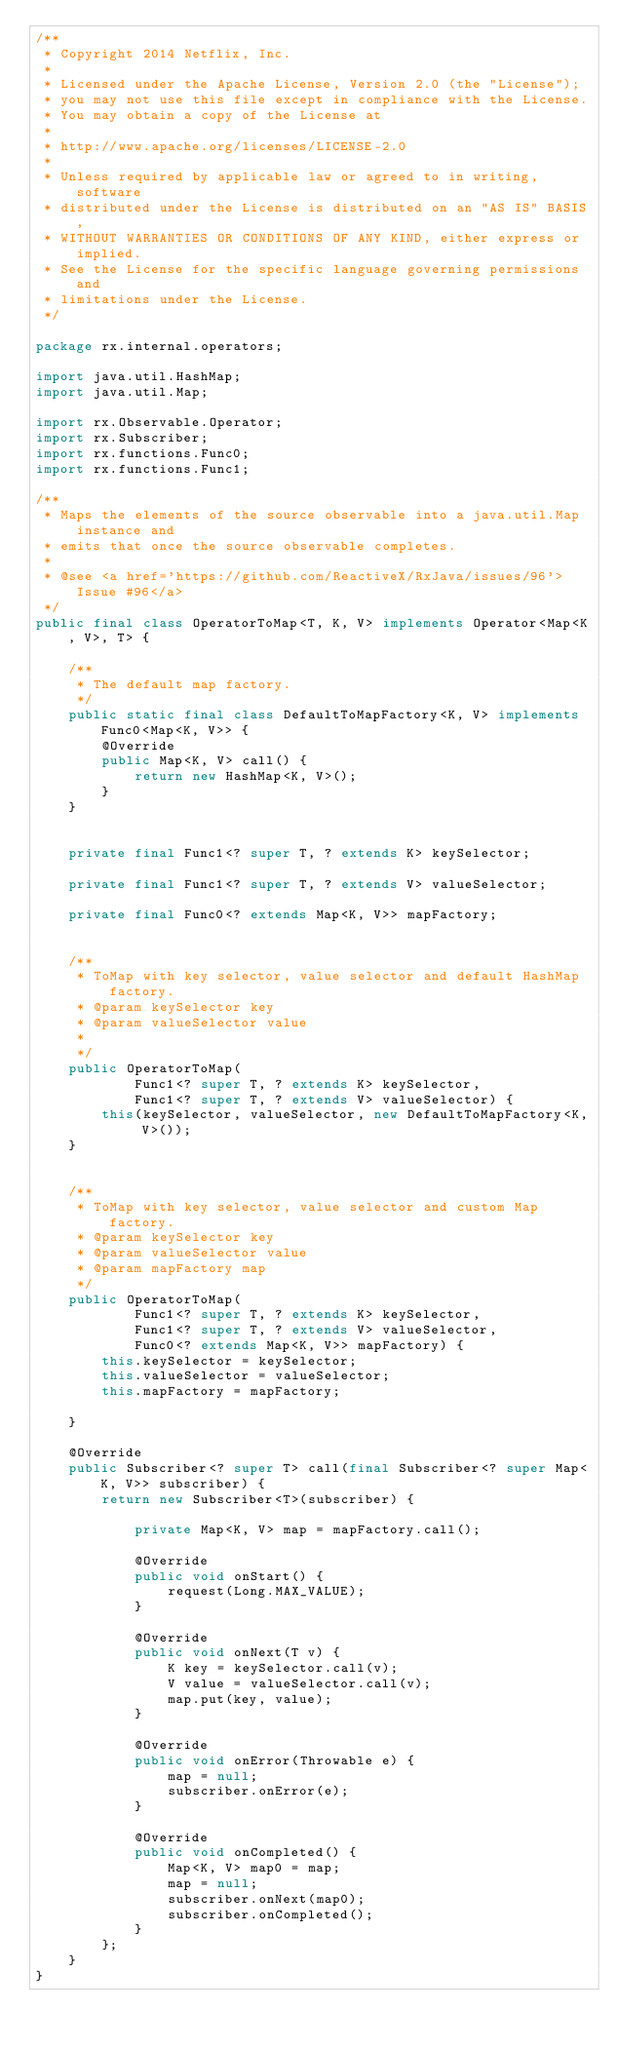<code> <loc_0><loc_0><loc_500><loc_500><_Java_>/**
 * Copyright 2014 Netflix, Inc.
 * 
 * Licensed under the Apache License, Version 2.0 (the "License");
 * you may not use this file except in compliance with the License.
 * You may obtain a copy of the License at
 * 
 * http://www.apache.org/licenses/LICENSE-2.0
 * 
 * Unless required by applicable law or agreed to in writing, software
 * distributed under the License is distributed on an "AS IS" BASIS,
 * WITHOUT WARRANTIES OR CONDITIONS OF ANY KIND, either express or implied.
 * See the License for the specific language governing permissions and
 * limitations under the License.
 */

package rx.internal.operators;

import java.util.HashMap;
import java.util.Map;

import rx.Observable.Operator;
import rx.Subscriber;
import rx.functions.Func0;
import rx.functions.Func1;

/**
 * Maps the elements of the source observable into a java.util.Map instance and
 * emits that once the source observable completes.
 * 
 * @see <a href='https://github.com/ReactiveX/RxJava/issues/96'>Issue #96</a>
 */
public final class OperatorToMap<T, K, V> implements Operator<Map<K, V>, T> {

    /**
     * The default map factory.
     */
    public static final class DefaultToMapFactory<K, V> implements Func0<Map<K, V>> {
        @Override
        public Map<K, V> call() {
            return new HashMap<K, V>();
        }
    }


    private final Func1<? super T, ? extends K> keySelector;

    private final Func1<? super T, ? extends V> valueSelector;

    private final Func0<? extends Map<K, V>> mapFactory;


    /**
     * ToMap with key selector, value selector and default HashMap factory.
     * @param keySelector key
     * @param valueSelector value
     *
     */
    public OperatorToMap(
            Func1<? super T, ? extends K> keySelector,
            Func1<? super T, ? extends V> valueSelector) {
        this(keySelector, valueSelector, new DefaultToMapFactory<K, V>());
    }


    /**
     * ToMap with key selector, value selector and custom Map factory.
     * @param keySelector key
     * @param valueSelector value
     * @param mapFactory map
     */
    public OperatorToMap(
            Func1<? super T, ? extends K> keySelector,
            Func1<? super T, ? extends V> valueSelector,
            Func0<? extends Map<K, V>> mapFactory) {
        this.keySelector = keySelector;
        this.valueSelector = valueSelector;
        this.mapFactory = mapFactory;

    }

    @Override
    public Subscriber<? super T> call(final Subscriber<? super Map<K, V>> subscriber) {
        return new Subscriber<T>(subscriber) {

            private Map<K, V> map = mapFactory.call();

            @Override
            public void onStart() {
                request(Long.MAX_VALUE);
            }
            
            @Override
            public void onNext(T v) {
                K key = keySelector.call(v);
                V value = valueSelector.call(v);
                map.put(key, value);
            }

            @Override
            public void onError(Throwable e) {
                map = null;
                subscriber.onError(e);
            }

            @Override
            public void onCompleted() {
                Map<K, V> map0 = map;
                map = null;
                subscriber.onNext(map0);
                subscriber.onCompleted();
            }
        };
    }
}
</code> 